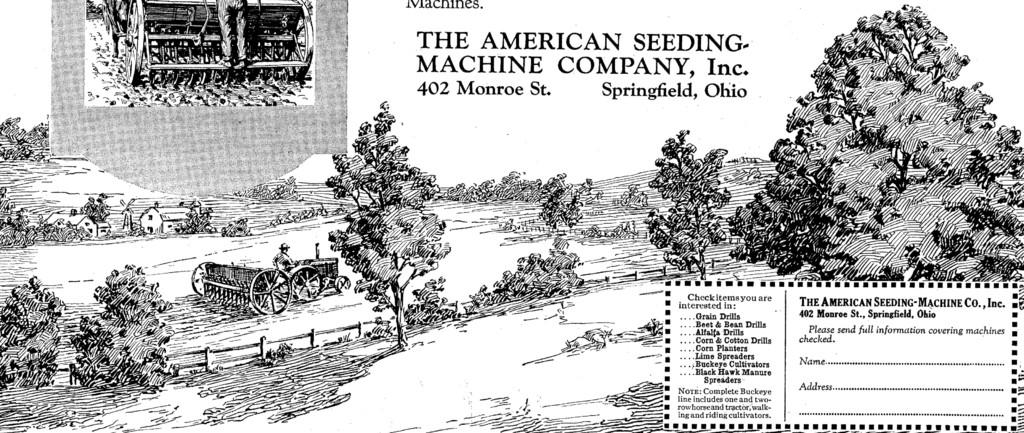What is the main object in the image that is not a natural element? The main object in the image that is not a natural element is a poster. Can you describe the color scheme of the poster? The poster is black and white. What natural elements can be seen in the image? Trees are visible in the image. What man-made structures can be seen in the image? There are vehicles, houses, and a poster in the image. Is there any text present in the image? Yes, there is text present in the image. What type of impulse can be seen affecting the downtown area in the image? There is no downtown area or impulse present in the image. How many bits of information can be found in the text of the image? There is no mention of bits of information in the image, as it contains text but not in a digital format. 